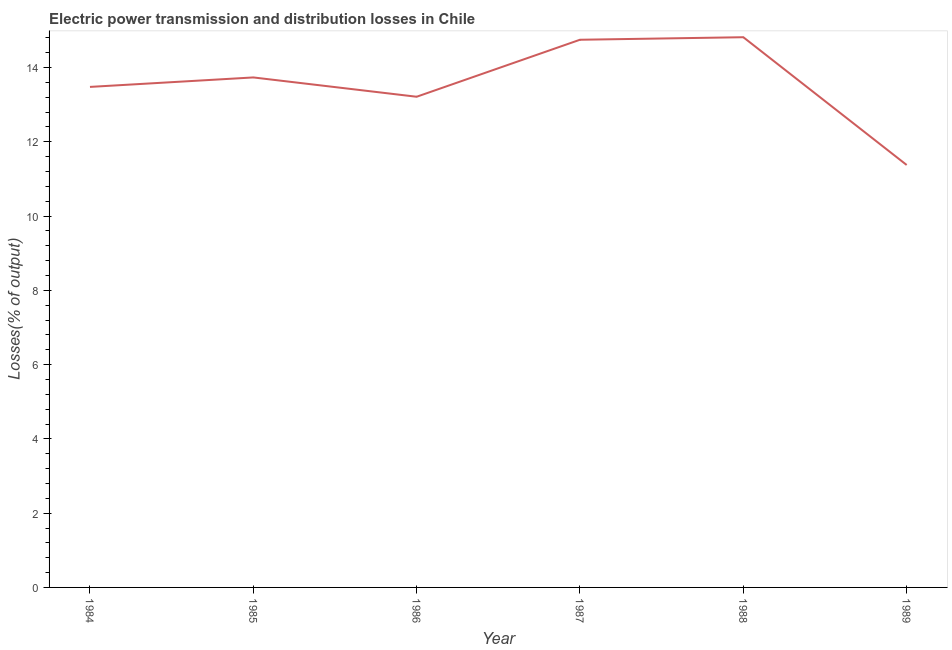What is the electric power transmission and distribution losses in 1985?
Make the answer very short. 13.73. Across all years, what is the maximum electric power transmission and distribution losses?
Give a very brief answer. 14.82. Across all years, what is the minimum electric power transmission and distribution losses?
Your answer should be very brief. 11.37. In which year was the electric power transmission and distribution losses maximum?
Ensure brevity in your answer.  1988. In which year was the electric power transmission and distribution losses minimum?
Your answer should be compact. 1989. What is the sum of the electric power transmission and distribution losses?
Provide a succinct answer. 81.36. What is the difference between the electric power transmission and distribution losses in 1984 and 1986?
Make the answer very short. 0.26. What is the average electric power transmission and distribution losses per year?
Keep it short and to the point. 13.56. What is the median electric power transmission and distribution losses?
Your answer should be very brief. 13.6. Do a majority of the years between 1989 and 1984 (inclusive) have electric power transmission and distribution losses greater than 10.8 %?
Provide a succinct answer. Yes. What is the ratio of the electric power transmission and distribution losses in 1985 to that in 1989?
Your answer should be compact. 1.21. Is the difference between the electric power transmission and distribution losses in 1986 and 1989 greater than the difference between any two years?
Your response must be concise. No. What is the difference between the highest and the second highest electric power transmission and distribution losses?
Your answer should be compact. 0.07. What is the difference between the highest and the lowest electric power transmission and distribution losses?
Keep it short and to the point. 3.44. Does the electric power transmission and distribution losses monotonically increase over the years?
Offer a very short reply. No. Are the values on the major ticks of Y-axis written in scientific E-notation?
Offer a terse response. No. Does the graph contain any zero values?
Provide a succinct answer. No. What is the title of the graph?
Provide a succinct answer. Electric power transmission and distribution losses in Chile. What is the label or title of the X-axis?
Offer a terse response. Year. What is the label or title of the Y-axis?
Your response must be concise. Losses(% of output). What is the Losses(% of output) of 1984?
Provide a short and direct response. 13.48. What is the Losses(% of output) in 1985?
Make the answer very short. 13.73. What is the Losses(% of output) of 1986?
Offer a terse response. 13.21. What is the Losses(% of output) in 1987?
Offer a very short reply. 14.75. What is the Losses(% of output) in 1988?
Your answer should be very brief. 14.82. What is the Losses(% of output) in 1989?
Keep it short and to the point. 11.37. What is the difference between the Losses(% of output) in 1984 and 1985?
Your answer should be compact. -0.26. What is the difference between the Losses(% of output) in 1984 and 1986?
Give a very brief answer. 0.26. What is the difference between the Losses(% of output) in 1984 and 1987?
Your answer should be very brief. -1.27. What is the difference between the Losses(% of output) in 1984 and 1988?
Provide a short and direct response. -1.34. What is the difference between the Losses(% of output) in 1984 and 1989?
Offer a very short reply. 2.1. What is the difference between the Losses(% of output) in 1985 and 1986?
Provide a succinct answer. 0.52. What is the difference between the Losses(% of output) in 1985 and 1987?
Provide a succinct answer. -1.01. What is the difference between the Losses(% of output) in 1985 and 1988?
Ensure brevity in your answer.  -1.08. What is the difference between the Losses(% of output) in 1985 and 1989?
Make the answer very short. 2.36. What is the difference between the Losses(% of output) in 1986 and 1987?
Your answer should be very brief. -1.53. What is the difference between the Losses(% of output) in 1986 and 1988?
Ensure brevity in your answer.  -1.6. What is the difference between the Losses(% of output) in 1986 and 1989?
Give a very brief answer. 1.84. What is the difference between the Losses(% of output) in 1987 and 1988?
Keep it short and to the point. -0.07. What is the difference between the Losses(% of output) in 1987 and 1989?
Offer a terse response. 3.37. What is the difference between the Losses(% of output) in 1988 and 1989?
Provide a succinct answer. 3.44. What is the ratio of the Losses(% of output) in 1984 to that in 1985?
Give a very brief answer. 0.98. What is the ratio of the Losses(% of output) in 1984 to that in 1986?
Make the answer very short. 1.02. What is the ratio of the Losses(% of output) in 1984 to that in 1987?
Give a very brief answer. 0.91. What is the ratio of the Losses(% of output) in 1984 to that in 1988?
Provide a succinct answer. 0.91. What is the ratio of the Losses(% of output) in 1984 to that in 1989?
Keep it short and to the point. 1.19. What is the ratio of the Losses(% of output) in 1985 to that in 1986?
Ensure brevity in your answer.  1.04. What is the ratio of the Losses(% of output) in 1985 to that in 1987?
Your answer should be very brief. 0.93. What is the ratio of the Losses(% of output) in 1985 to that in 1988?
Your answer should be very brief. 0.93. What is the ratio of the Losses(% of output) in 1985 to that in 1989?
Offer a terse response. 1.21. What is the ratio of the Losses(% of output) in 1986 to that in 1987?
Your response must be concise. 0.9. What is the ratio of the Losses(% of output) in 1986 to that in 1988?
Give a very brief answer. 0.89. What is the ratio of the Losses(% of output) in 1986 to that in 1989?
Offer a terse response. 1.16. What is the ratio of the Losses(% of output) in 1987 to that in 1988?
Keep it short and to the point. 0.99. What is the ratio of the Losses(% of output) in 1987 to that in 1989?
Make the answer very short. 1.3. What is the ratio of the Losses(% of output) in 1988 to that in 1989?
Keep it short and to the point. 1.3. 